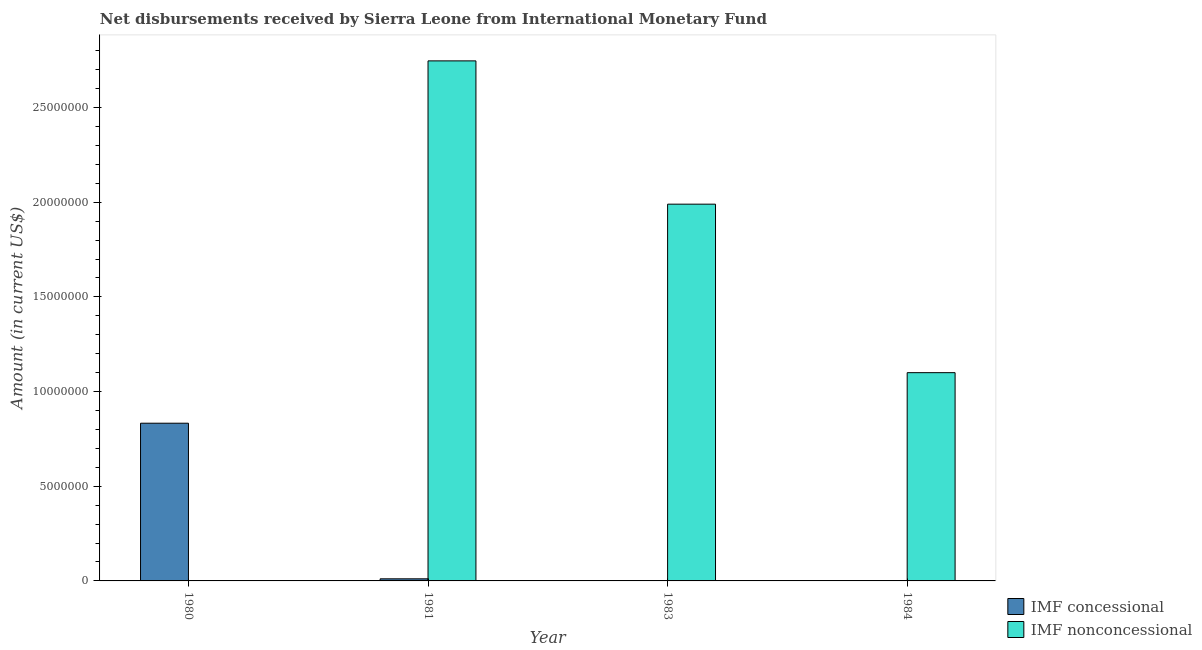Are the number of bars per tick equal to the number of legend labels?
Provide a short and direct response. No. How many bars are there on the 4th tick from the left?
Keep it short and to the point. 1. What is the net concessional disbursements from imf in 1981?
Your response must be concise. 1.11e+05. Across all years, what is the maximum net concessional disbursements from imf?
Give a very brief answer. 8.33e+06. In which year was the net concessional disbursements from imf maximum?
Provide a short and direct response. 1980. What is the total net concessional disbursements from imf in the graph?
Offer a terse response. 8.44e+06. What is the difference between the net non concessional disbursements from imf in 1983 and that in 1984?
Offer a terse response. 8.90e+06. What is the difference between the net concessional disbursements from imf in 1981 and the net non concessional disbursements from imf in 1983?
Offer a terse response. 1.11e+05. What is the average net concessional disbursements from imf per year?
Your answer should be compact. 2.11e+06. In how many years, is the net concessional disbursements from imf greater than 3000000 US$?
Keep it short and to the point. 1. What is the ratio of the net concessional disbursements from imf in 1980 to that in 1981?
Keep it short and to the point. 75.05. Is the net non concessional disbursements from imf in 1981 less than that in 1984?
Keep it short and to the point. No. What is the difference between the highest and the second highest net non concessional disbursements from imf?
Provide a short and direct response. 7.57e+06. What is the difference between the highest and the lowest net non concessional disbursements from imf?
Offer a very short reply. 2.75e+07. In how many years, is the net non concessional disbursements from imf greater than the average net non concessional disbursements from imf taken over all years?
Keep it short and to the point. 2. How many bars are there?
Keep it short and to the point. 5. Are all the bars in the graph horizontal?
Keep it short and to the point. No. How many years are there in the graph?
Your answer should be very brief. 4. Where does the legend appear in the graph?
Your answer should be compact. Bottom right. How are the legend labels stacked?
Make the answer very short. Vertical. What is the title of the graph?
Provide a succinct answer. Net disbursements received by Sierra Leone from International Monetary Fund. What is the label or title of the X-axis?
Your answer should be very brief. Year. What is the Amount (in current US$) of IMF concessional in 1980?
Keep it short and to the point. 8.33e+06. What is the Amount (in current US$) in IMF nonconcessional in 1980?
Ensure brevity in your answer.  0. What is the Amount (in current US$) in IMF concessional in 1981?
Provide a short and direct response. 1.11e+05. What is the Amount (in current US$) of IMF nonconcessional in 1981?
Your answer should be compact. 2.75e+07. What is the Amount (in current US$) in IMF concessional in 1983?
Give a very brief answer. 0. What is the Amount (in current US$) of IMF nonconcessional in 1983?
Provide a succinct answer. 1.99e+07. What is the Amount (in current US$) of IMF nonconcessional in 1984?
Keep it short and to the point. 1.10e+07. Across all years, what is the maximum Amount (in current US$) in IMF concessional?
Your answer should be very brief. 8.33e+06. Across all years, what is the maximum Amount (in current US$) in IMF nonconcessional?
Offer a very short reply. 2.75e+07. Across all years, what is the minimum Amount (in current US$) of IMF concessional?
Your answer should be very brief. 0. Across all years, what is the minimum Amount (in current US$) in IMF nonconcessional?
Offer a terse response. 0. What is the total Amount (in current US$) of IMF concessional in the graph?
Provide a succinct answer. 8.44e+06. What is the total Amount (in current US$) of IMF nonconcessional in the graph?
Your answer should be very brief. 5.84e+07. What is the difference between the Amount (in current US$) in IMF concessional in 1980 and that in 1981?
Offer a terse response. 8.22e+06. What is the difference between the Amount (in current US$) in IMF nonconcessional in 1981 and that in 1983?
Make the answer very short. 7.57e+06. What is the difference between the Amount (in current US$) of IMF nonconcessional in 1981 and that in 1984?
Provide a succinct answer. 1.65e+07. What is the difference between the Amount (in current US$) of IMF nonconcessional in 1983 and that in 1984?
Provide a succinct answer. 8.90e+06. What is the difference between the Amount (in current US$) of IMF concessional in 1980 and the Amount (in current US$) of IMF nonconcessional in 1981?
Provide a short and direct response. -1.91e+07. What is the difference between the Amount (in current US$) of IMF concessional in 1980 and the Amount (in current US$) of IMF nonconcessional in 1983?
Your answer should be compact. -1.16e+07. What is the difference between the Amount (in current US$) of IMF concessional in 1980 and the Amount (in current US$) of IMF nonconcessional in 1984?
Offer a very short reply. -2.67e+06. What is the difference between the Amount (in current US$) in IMF concessional in 1981 and the Amount (in current US$) in IMF nonconcessional in 1983?
Your answer should be very brief. -1.98e+07. What is the difference between the Amount (in current US$) in IMF concessional in 1981 and the Amount (in current US$) in IMF nonconcessional in 1984?
Your response must be concise. -1.09e+07. What is the average Amount (in current US$) of IMF concessional per year?
Keep it short and to the point. 2.11e+06. What is the average Amount (in current US$) of IMF nonconcessional per year?
Make the answer very short. 1.46e+07. In the year 1981, what is the difference between the Amount (in current US$) of IMF concessional and Amount (in current US$) of IMF nonconcessional?
Your answer should be compact. -2.74e+07. What is the ratio of the Amount (in current US$) of IMF concessional in 1980 to that in 1981?
Make the answer very short. 75.05. What is the ratio of the Amount (in current US$) in IMF nonconcessional in 1981 to that in 1983?
Your response must be concise. 1.38. What is the ratio of the Amount (in current US$) in IMF nonconcessional in 1981 to that in 1984?
Provide a succinct answer. 2.5. What is the ratio of the Amount (in current US$) in IMF nonconcessional in 1983 to that in 1984?
Your answer should be compact. 1.81. What is the difference between the highest and the second highest Amount (in current US$) in IMF nonconcessional?
Provide a succinct answer. 7.57e+06. What is the difference between the highest and the lowest Amount (in current US$) of IMF concessional?
Offer a very short reply. 8.33e+06. What is the difference between the highest and the lowest Amount (in current US$) in IMF nonconcessional?
Offer a terse response. 2.75e+07. 